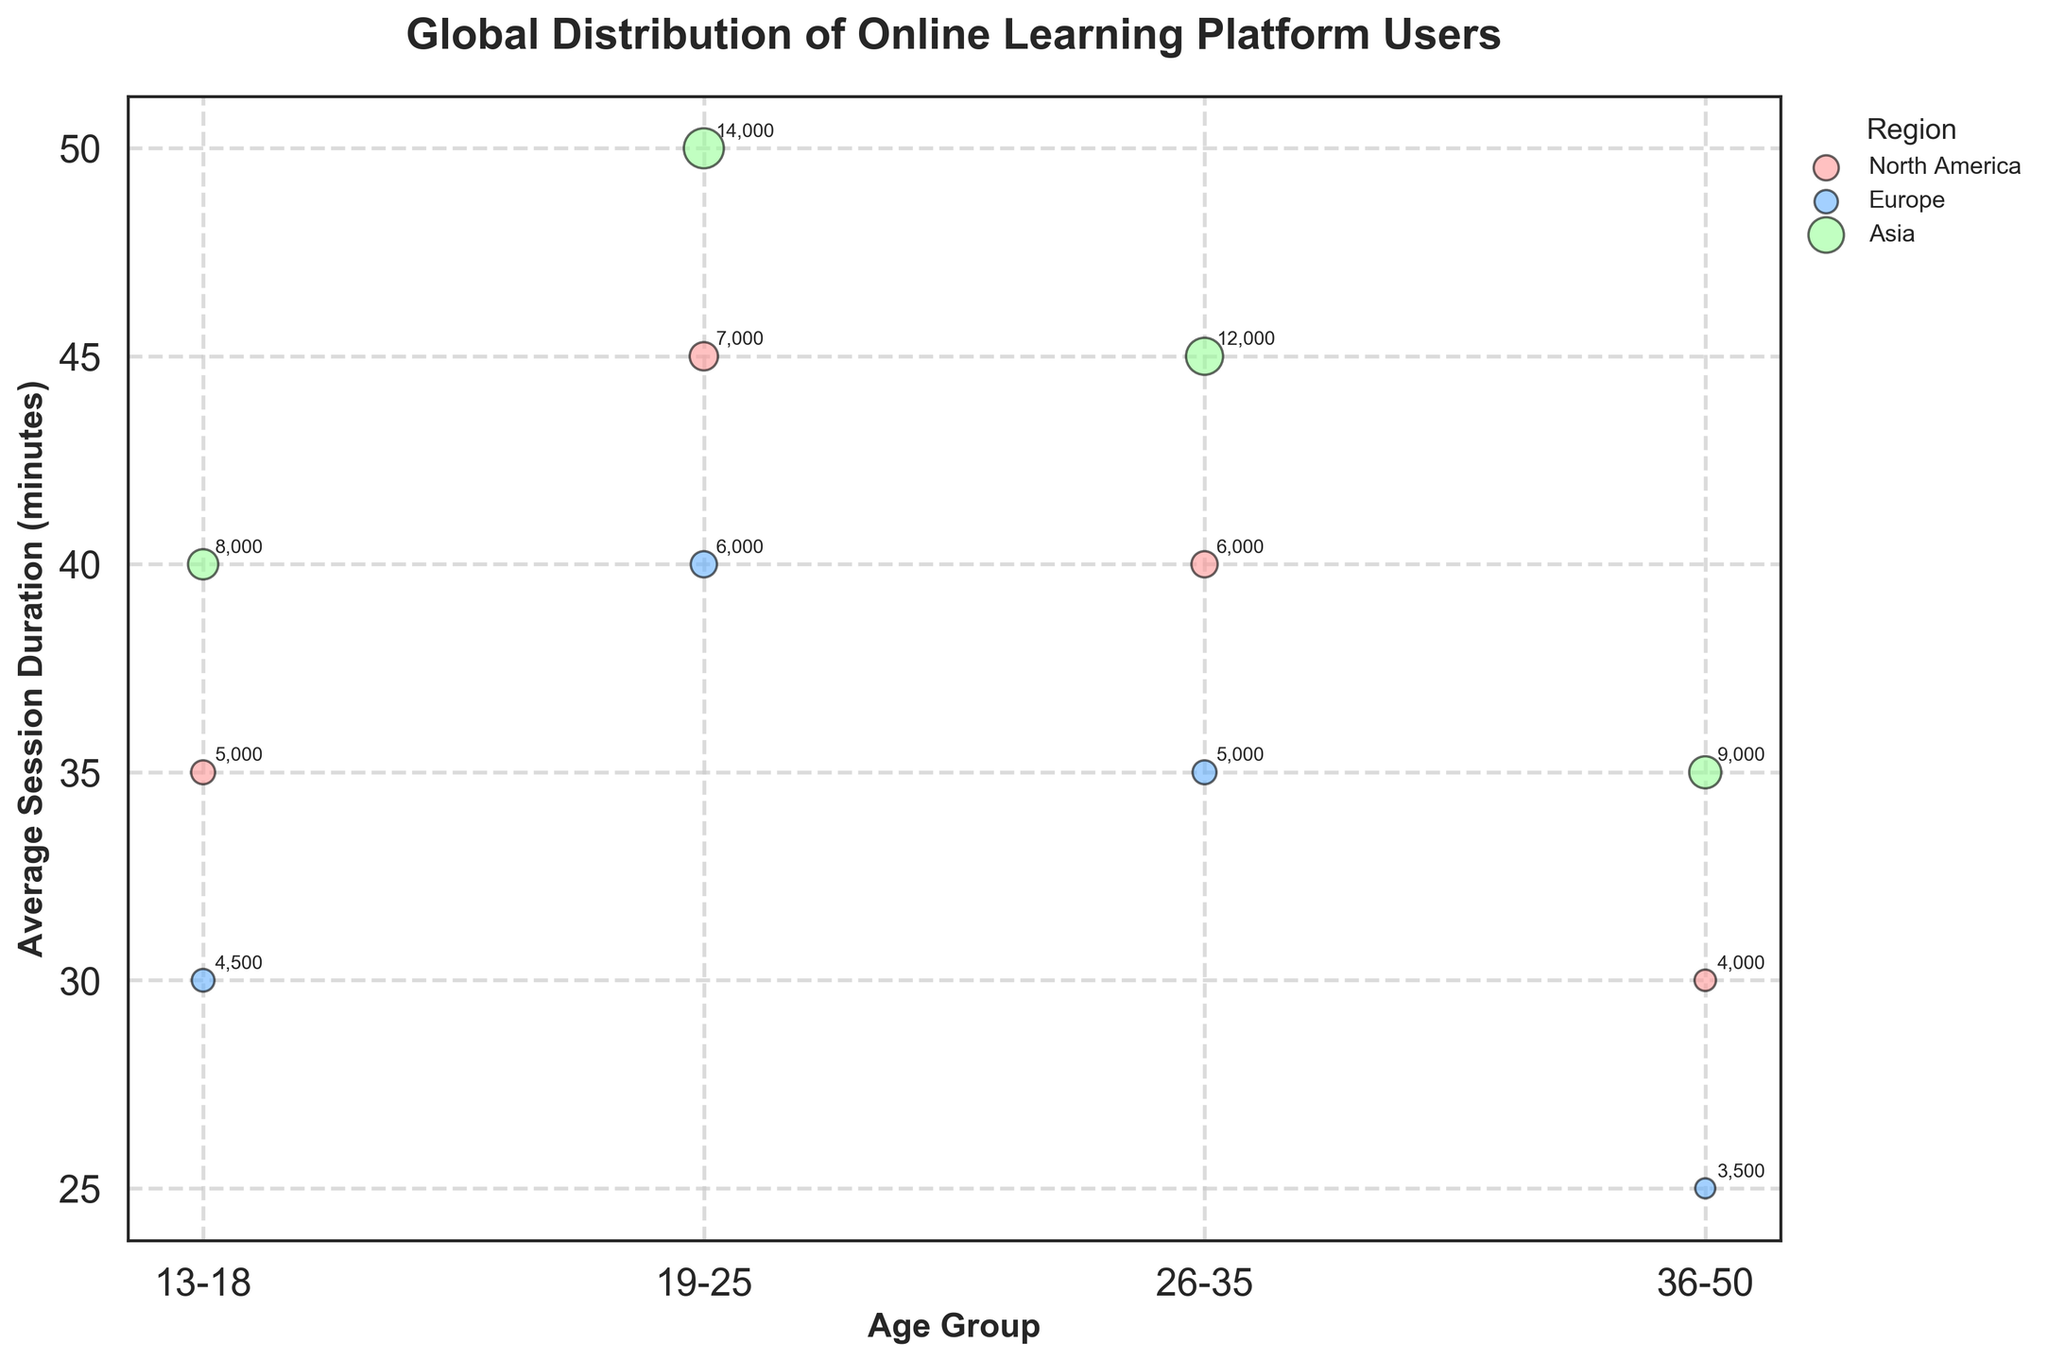What is the title of the bubble chart? The title of the bubble chart is positioned at the top of the figure and provides a summary of what the chart is about. The title is "Global Distribution of Online Learning Platform Users."
Answer: Global Distribution of Online Learning Platform Users What is the average session duration for users aged 19-25 in Asia? To find the average session duration for the specified age group and region, locate the corresponding bubble on the chart. The label next to the bubble will show the average session duration, which for users aged 19-25 in Asia is 50 minutes.
Answer: 50 minutes Which region has the highest number of users aged 26-35? To determine which region has the highest number of users for the 26-35 age group, compare the sizes of the bubbles associated with that age group across different regions. Larger bubbles represent more users. The bubble corresponding to Asia is the largest in this age group, indicating the highest number of users.
Answer: Asia How does the average session duration for users aged 36-50 in North America compare to Europe? To compare the average session duration, look at both North America's and Europe's bubbles for the age group 36-50. North America's bubble has an average session duration of 30 minutes, whereas Europe's bubble has 25 minutes, making North America's duration higher.
Answer: North America has a higher average session duration How many users are there in Europe aged 13-18? Check the bubble corresponding to users aged 13-18 in Europe. The bubble should have a label indicating the number of users, which is 4,500.
Answer: 4,500 Which age group and region combination has the longest average session duration overall? To find the combination with the longest session duration, identify the bubble with the highest position on the y-axis. The bubble for users aged 19-25 in Asia has the highest average session duration at 50 minutes.
Answer: 19-25 in Asia What is the total number of users in the 13-18 age group across all regions? Sum up the number of users for the 13-18 age group across North America (5,000), Europe (4,500), and Asia (8,000). The total is 5,000 + 4,500 + 8,000 = 17,500.
Answer: 17,500 What is the color representing Europe? The color representing Europe can be found by looking at the legend on the figure. According to the legend, Europe is represented by a blueish color.
Answer: Blueish Among users aged 26-35, which region has the shortest average session duration? Compare the average session durations for the 26-35 age group across different regions by looking at the y-axis positions of their bubbles. North America's bubble has the shortest average session duration of 40 minutes.
Answer: North America 